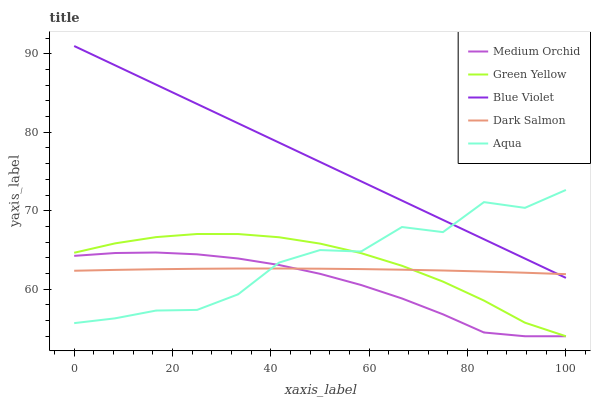Does Medium Orchid have the minimum area under the curve?
Answer yes or no. Yes. Does Blue Violet have the maximum area under the curve?
Answer yes or no. Yes. Does Aqua have the minimum area under the curve?
Answer yes or no. No. Does Aqua have the maximum area under the curve?
Answer yes or no. No. Is Blue Violet the smoothest?
Answer yes or no. Yes. Is Aqua the roughest?
Answer yes or no. Yes. Is Medium Orchid the smoothest?
Answer yes or no. No. Is Medium Orchid the roughest?
Answer yes or no. No. Does Green Yellow have the lowest value?
Answer yes or no. Yes. Does Aqua have the lowest value?
Answer yes or no. No. Does Blue Violet have the highest value?
Answer yes or no. Yes. Does Medium Orchid have the highest value?
Answer yes or no. No. Is Green Yellow less than Blue Violet?
Answer yes or no. Yes. Is Blue Violet greater than Green Yellow?
Answer yes or no. Yes. Does Dark Salmon intersect Green Yellow?
Answer yes or no. Yes. Is Dark Salmon less than Green Yellow?
Answer yes or no. No. Is Dark Salmon greater than Green Yellow?
Answer yes or no. No. Does Green Yellow intersect Blue Violet?
Answer yes or no. No. 